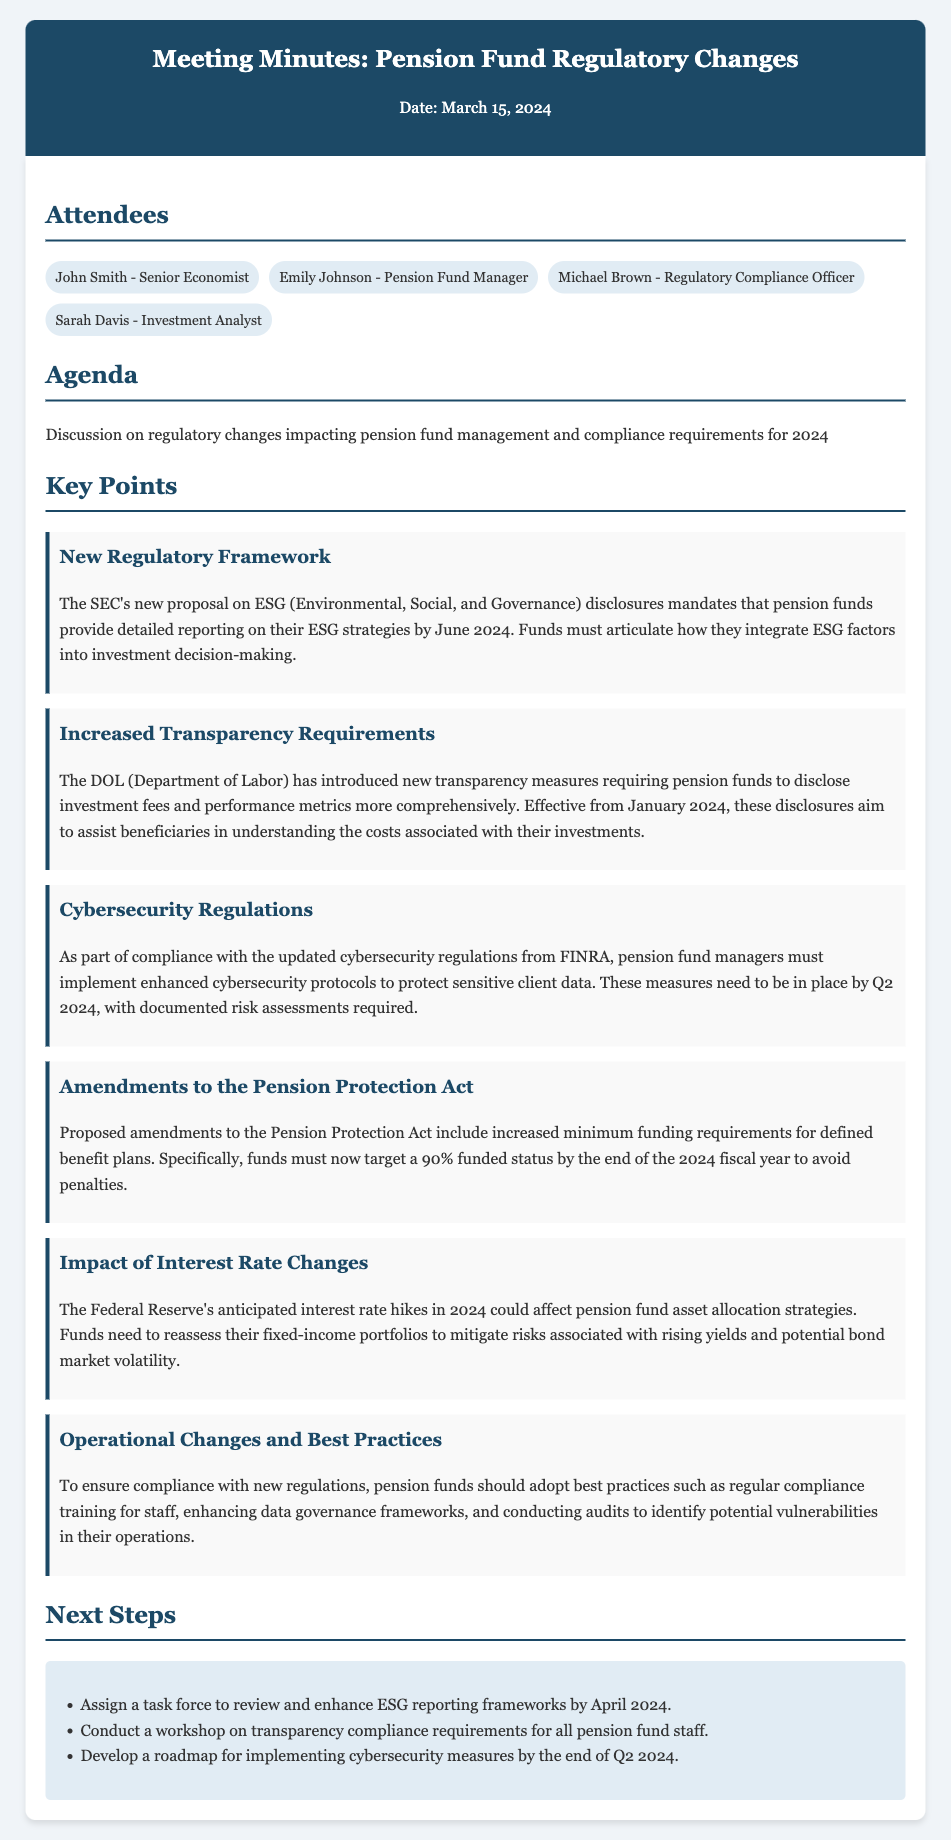What is the date of the meeting? The date of the meeting is mentioned in the header of the document, which is March 15, 2024.
Answer: March 15, 2024 Who introduced the new regulatory framework on ESG disclosures? The new regulatory framework is introduced by the SEC as noted in the key points section.
Answer: SEC What is the deadline for ESG reporting? The document mentions that the deadline for ESG reporting is June 2024.
Answer: June 2024 What is the new minimum funded status required to avoid penalties? The required minimum funded status to avoid penalties is stated as 90% by the end of the 2024 fiscal year.
Answer: 90% Which organization is associated with the new transparency measures? The new transparency measures are associated with the Department of Labor as indicated in the key points.
Answer: Department of Labor How many attendees are listed in the document? The document lists four attendees in the attendees section.
Answer: Four What is one of the next steps mentioned in relation to ESG reporting frameworks? One next step is to assign a task force to review and enhance ESG reporting frameworks.
Answer: Assign a task force What are pension fund managers required to implement according to updated cybersecurity regulations? Pension fund managers are required to implement enhanced cybersecurity protocols as per the key points.
Answer: Enhanced cybersecurity protocols What should pension funds conduct to identify potential vulnerabilities? Pension funds should conduct audits to identify potential vulnerabilities in their operations as mentioned in the key points.
Answer: Audits 